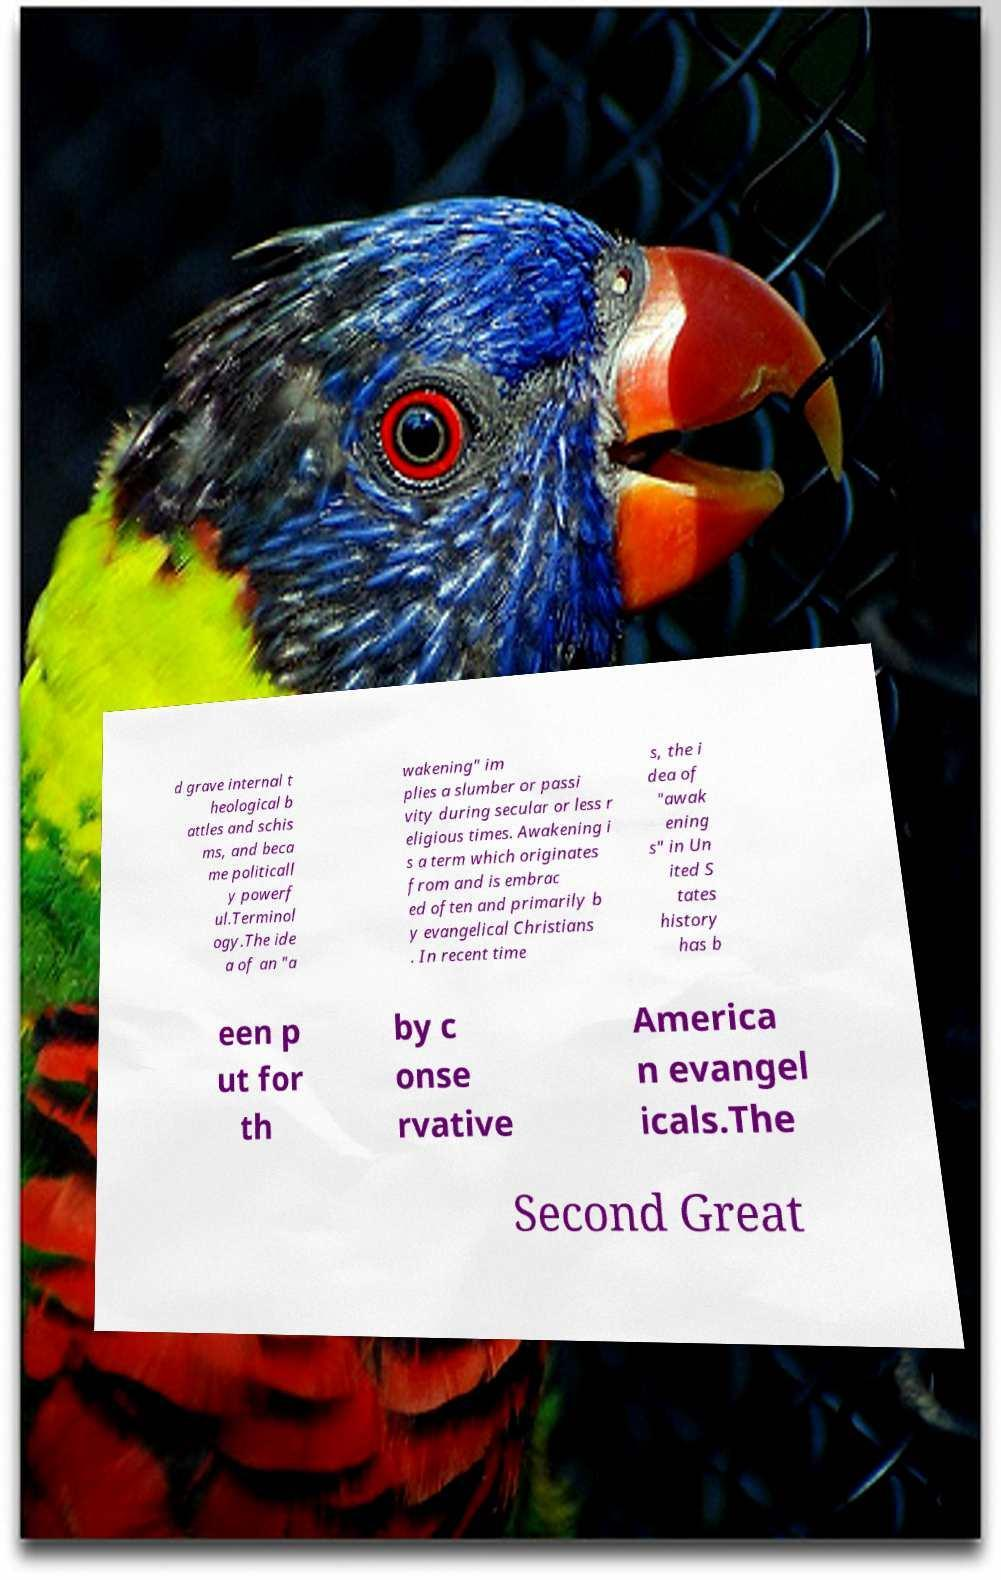There's text embedded in this image that I need extracted. Can you transcribe it verbatim? d grave internal t heological b attles and schis ms, and beca me politicall y powerf ul.Terminol ogy.The ide a of an "a wakening" im plies a slumber or passi vity during secular or less r eligious times. Awakening i s a term which originates from and is embrac ed often and primarily b y evangelical Christians . In recent time s, the i dea of "awak ening s" in Un ited S tates history has b een p ut for th by c onse rvative America n evangel icals.The Second Great 